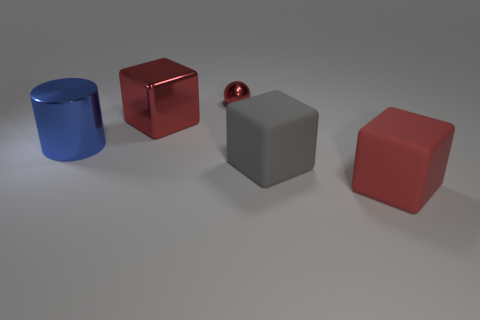Add 3 small yellow metallic spheres. How many objects exist? 8 Subtract all cubes. How many objects are left? 2 Subtract 0 green cylinders. How many objects are left? 5 Subtract all big gray matte cubes. Subtract all yellow spheres. How many objects are left? 4 Add 4 big gray things. How many big gray things are left? 5 Add 5 tiny green matte cylinders. How many tiny green matte cylinders exist? 5 